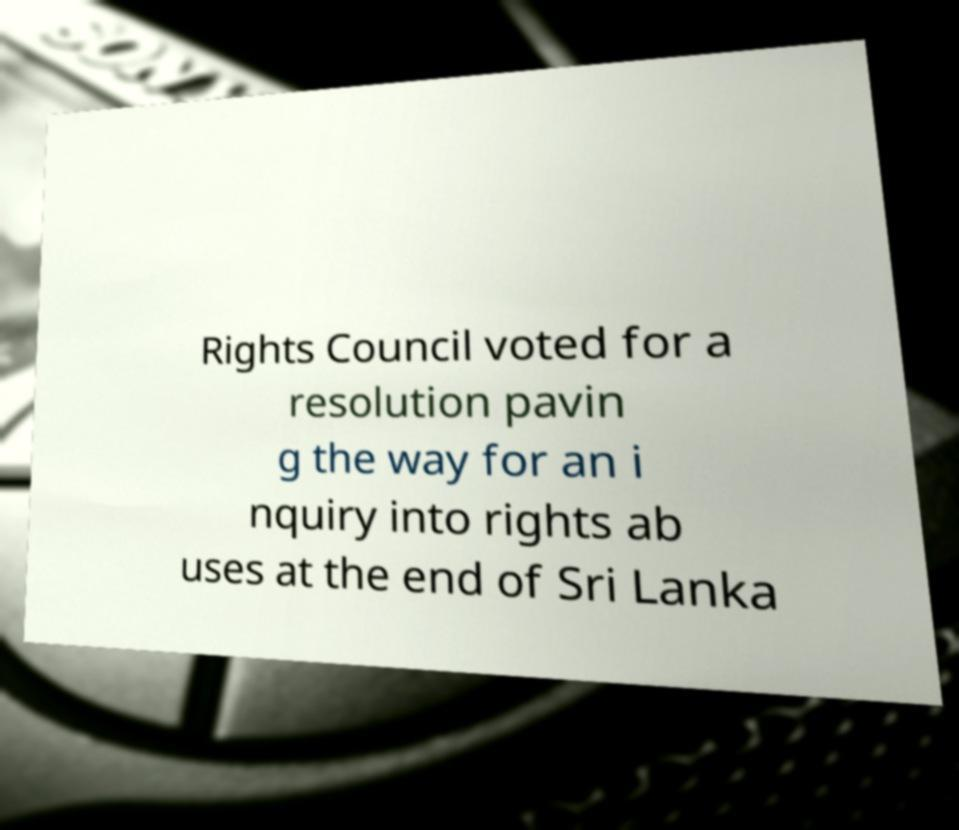Can you read and provide the text displayed in the image?This photo seems to have some interesting text. Can you extract and type it out for me? Rights Council voted for a resolution pavin g the way for an i nquiry into rights ab uses at the end of Sri Lanka 